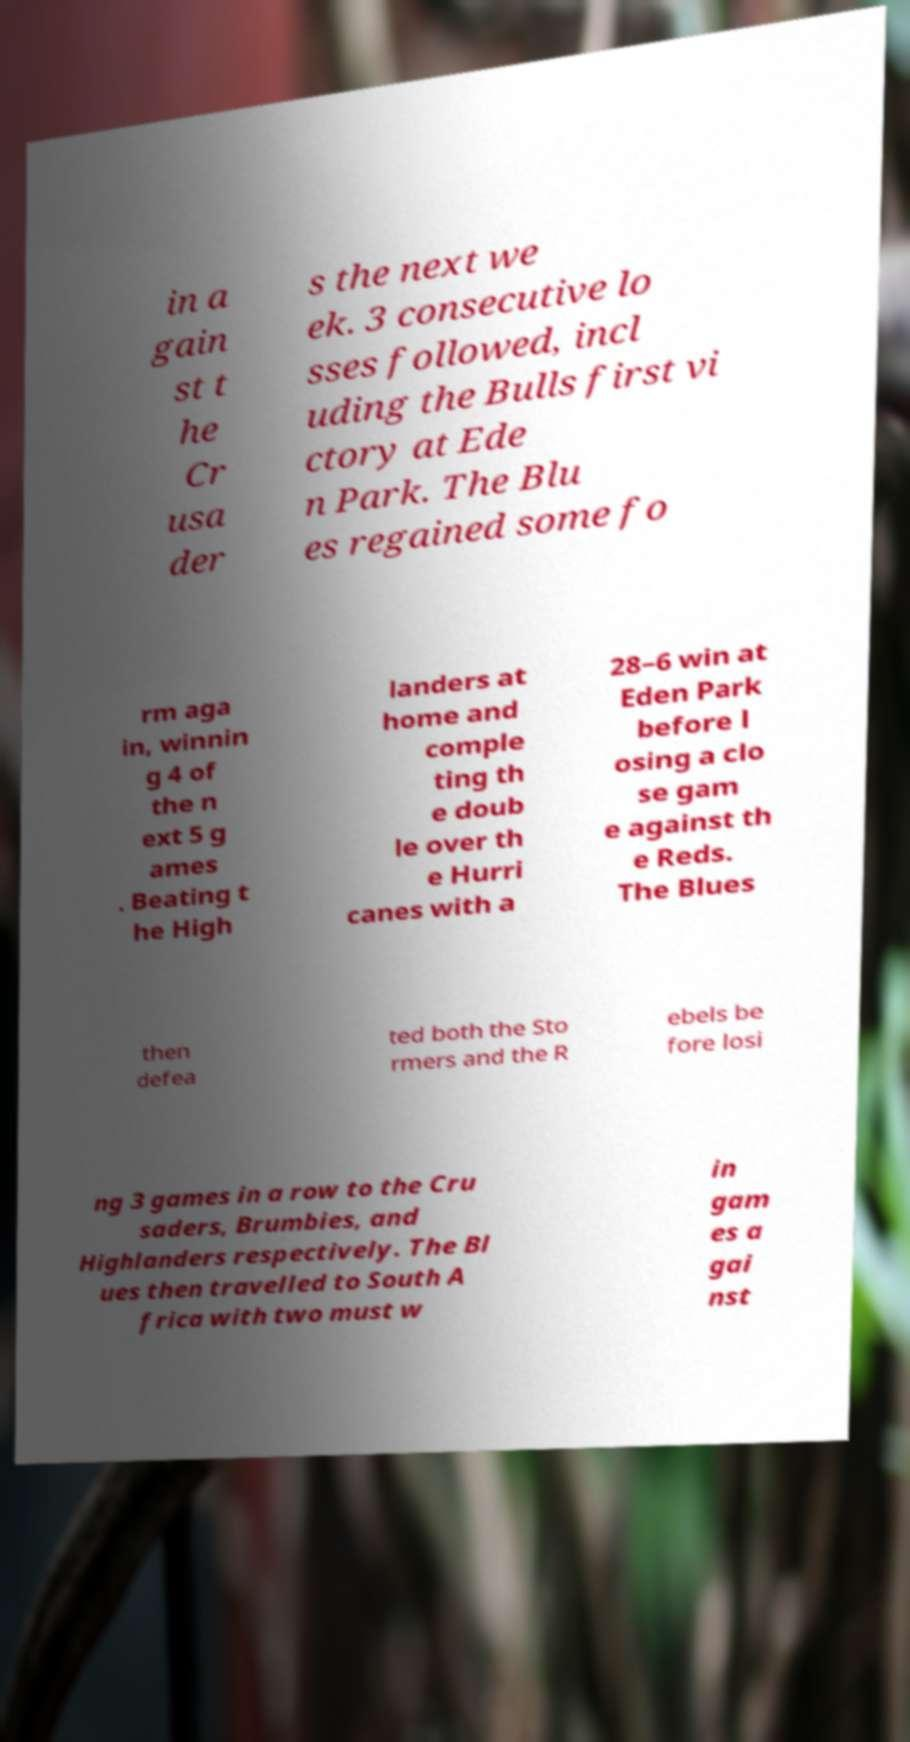Could you extract and type out the text from this image? in a gain st t he Cr usa der s the next we ek. 3 consecutive lo sses followed, incl uding the Bulls first vi ctory at Ede n Park. The Blu es regained some fo rm aga in, winnin g 4 of the n ext 5 g ames . Beating t he High landers at home and comple ting th e doub le over th e Hurri canes with a 28–6 win at Eden Park before l osing a clo se gam e against th e Reds. The Blues then defea ted both the Sto rmers and the R ebels be fore losi ng 3 games in a row to the Cru saders, Brumbies, and Highlanders respectively. The Bl ues then travelled to South A frica with two must w in gam es a gai nst 